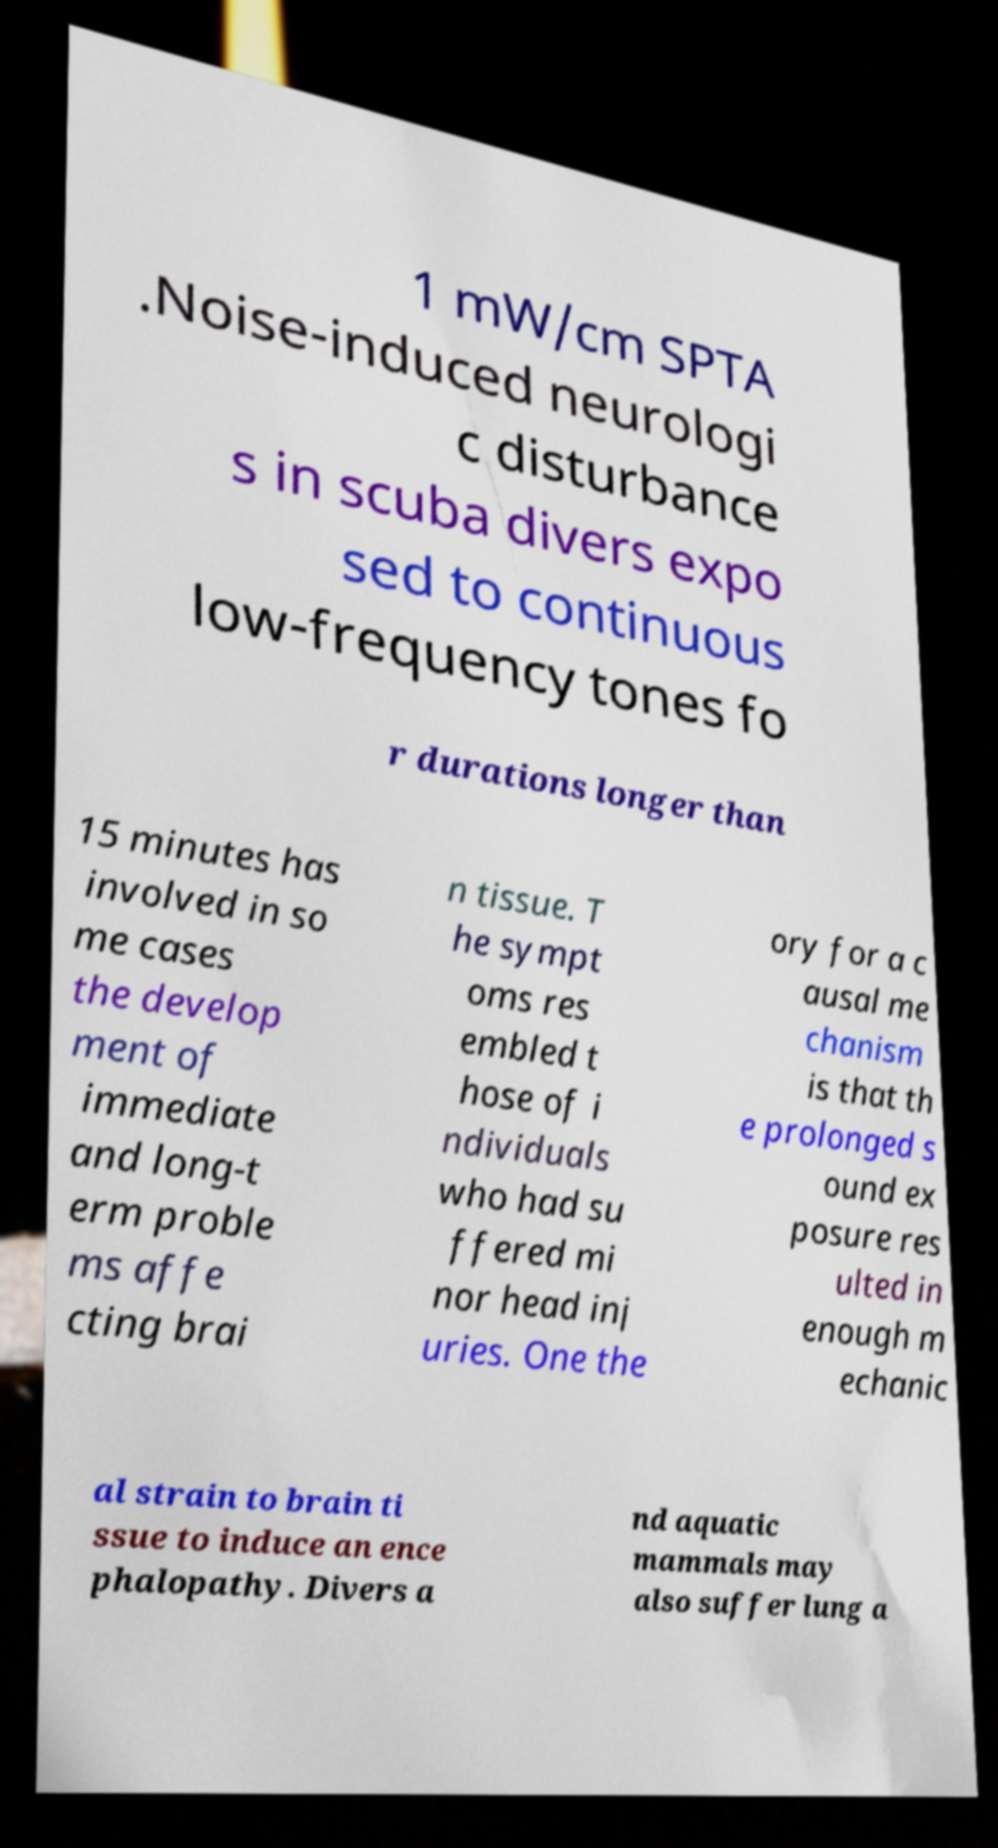There's text embedded in this image that I need extracted. Can you transcribe it verbatim? 1 mW/cm SPTA .Noise-induced neurologi c disturbance s in scuba divers expo sed to continuous low-frequency tones fo r durations longer than 15 minutes has involved in so me cases the develop ment of immediate and long-t erm proble ms affe cting brai n tissue. T he sympt oms res embled t hose of i ndividuals who had su ffered mi nor head inj uries. One the ory for a c ausal me chanism is that th e prolonged s ound ex posure res ulted in enough m echanic al strain to brain ti ssue to induce an ence phalopathy. Divers a nd aquatic mammals may also suffer lung a 